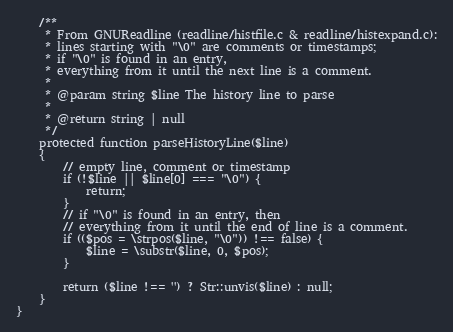Convert code to text. <code><loc_0><loc_0><loc_500><loc_500><_PHP_>    /**
     * From GNUReadline (readline/histfile.c & readline/histexpand.c):
     * lines starting with "\0" are comments or timestamps;
     * if "\0" is found in an entry,
     * everything from it until the next line is a comment.
     *
     * @param string $line The history line to parse
     *
     * @return string | null
     */
    protected function parseHistoryLine($line)
    {
        // empty line, comment or timestamp
        if (!$line || $line[0] === "\0") {
            return;
        }
        // if "\0" is found in an entry, then
        // everything from it until the end of line is a comment.
        if (($pos = \strpos($line, "\0")) !== false) {
            $line = \substr($line, 0, $pos);
        }

        return ($line !== '') ? Str::unvis($line) : null;
    }
}
</code> 